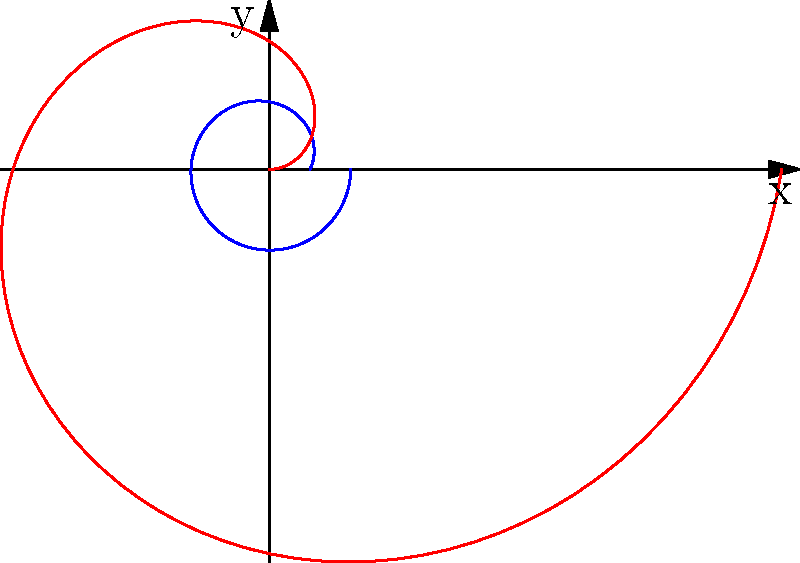In the polar plot above, two common neural network activation functions are represented. Which function corresponds to the blue curve, and what is its mathematical expression in terms of $\theta$? To answer this question, let's analyze the plot step-by-step:

1. We see two curves plotted in polar coordinates: a blue curve and a red curve.

2. The blue curve appears to be smooth and bounded between 0 and 1, which is characteristic of the sigmoid function.

3. The red curve shows a sharp transition at $\theta = 0$ and increases linearly after that point, which is typical of the ReLU (Rectified Linear Unit) function.

4. Given that the question asks about the blue curve, we focus on the sigmoid function.

5. The sigmoid function in Cartesian coordinates is typically expressed as:

   $$f(x) = \frac{1}{1 + e^{-x}}$$

6. To represent this in polar coordinates, we replace $x$ with $\theta$:

   $$f(\theta) = \frac{1}{1 + e^{-\theta}}$$

7. This expression gives the radial distance $r$ as a function of the angle $\theta$ in polar coordinates.

Therefore, the blue curve represents the sigmoid function, and its mathematical expression in terms of $\theta$ is $\frac{1}{1 + e^{-\theta}}$.
Answer: Sigmoid function: $\frac{1}{1 + e^{-\theta}}$ 